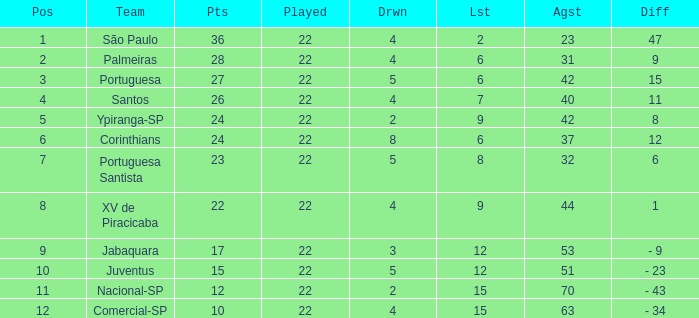Which Played has a Lost larger than 9, and a Points smaller than 15, and a Position smaller than 12, and a Drawn smaller than 2? None. 